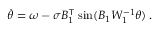Convert formula to latex. <formula><loc_0><loc_0><loc_500><loc_500>\begin{array} { r } { \ D o t { \theta } = \omega - \sigma B _ { 1 } ^ { \top } \sin ( B _ { 1 } W _ { 1 } ^ { - 1 } \theta ) \, . } \end{array}</formula> 